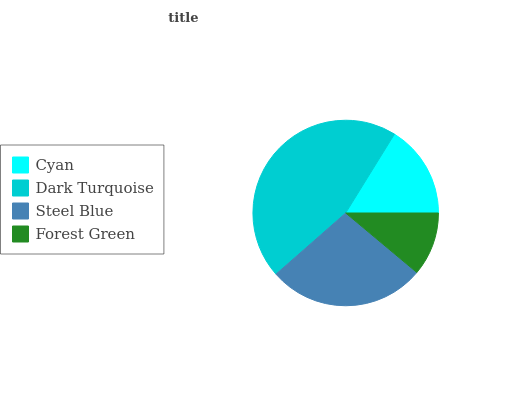Is Forest Green the minimum?
Answer yes or no. Yes. Is Dark Turquoise the maximum?
Answer yes or no. Yes. Is Steel Blue the minimum?
Answer yes or no. No. Is Steel Blue the maximum?
Answer yes or no. No. Is Dark Turquoise greater than Steel Blue?
Answer yes or no. Yes. Is Steel Blue less than Dark Turquoise?
Answer yes or no. Yes. Is Steel Blue greater than Dark Turquoise?
Answer yes or no. No. Is Dark Turquoise less than Steel Blue?
Answer yes or no. No. Is Steel Blue the high median?
Answer yes or no. Yes. Is Cyan the low median?
Answer yes or no. Yes. Is Dark Turquoise the high median?
Answer yes or no. No. Is Steel Blue the low median?
Answer yes or no. No. 